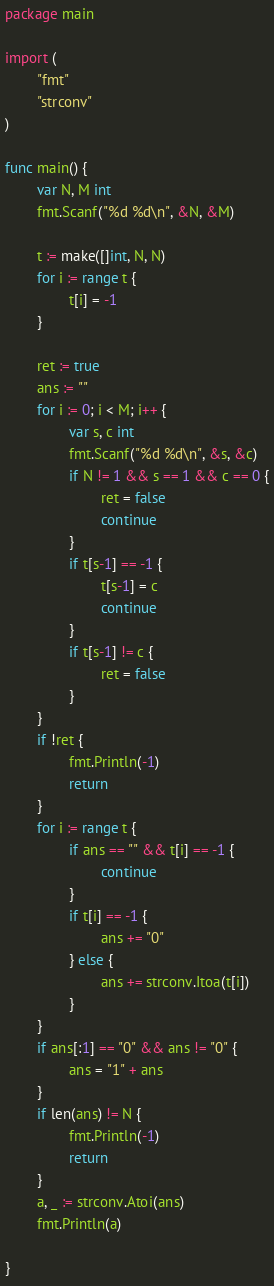<code> <loc_0><loc_0><loc_500><loc_500><_Go_>package main

import (
        "fmt"
        "strconv"
)

func main() {
        var N, M int
        fmt.Scanf("%d %d\n", &N, &M)

        t := make([]int, N, N)
        for i := range t {
                t[i] = -1
        }

        ret := true
        ans := ""
        for i := 0; i < M; i++ {
                var s, c int
                fmt.Scanf("%d %d\n", &s, &c)
                if N != 1 && s == 1 && c == 0 {
                        ret = false
                        continue
                }
                if t[s-1] == -1 {
                        t[s-1] = c
                        continue
                }
                if t[s-1] != c {
                        ret = false
                }
        }
        if !ret {
                fmt.Println(-1)
                return
        }
        for i := range t {
                if ans == "" && t[i] == -1 {
                        continue
                }
                if t[i] == -1 {
                        ans += "0"
                } else {
                        ans += strconv.Itoa(t[i])
                }
        }
        if ans[:1] == "0" && ans != "0" {
                ans = "1" + ans
        }
        if len(ans) != N {
                fmt.Println(-1)
                return
        }
        a, _ := strconv.Atoi(ans)
        fmt.Println(a)

}</code> 